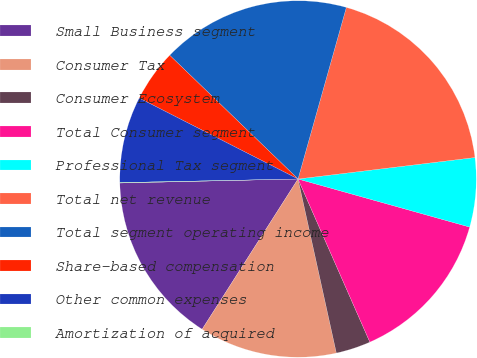Convert chart. <chart><loc_0><loc_0><loc_500><loc_500><pie_chart><fcel>Small Business segment<fcel>Consumer Tax<fcel>Consumer Ecosystem<fcel>Total Consumer segment<fcel>Professional Tax segment<fcel>Total net revenue<fcel>Total segment operating income<fcel>Share-based compensation<fcel>Other common expenses<fcel>Amortization of acquired<nl><fcel>15.6%<fcel>12.49%<fcel>3.15%<fcel>14.05%<fcel>6.27%<fcel>18.71%<fcel>17.16%<fcel>4.71%<fcel>7.82%<fcel>0.04%<nl></chart> 